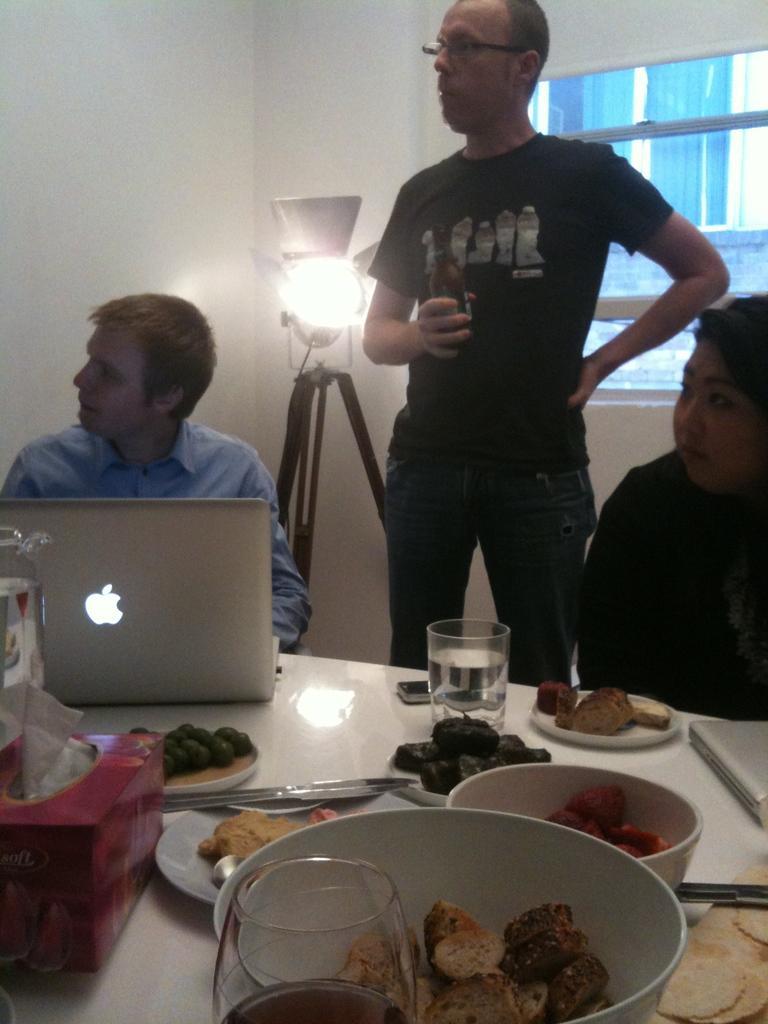How would you summarize this image in a sentence or two? In this picture we can see three people, two are seated on the chair and one person standing, in front of them we can find a laptop, bowls, glasses, tissues and some food on the table, in the background we can see a light. 